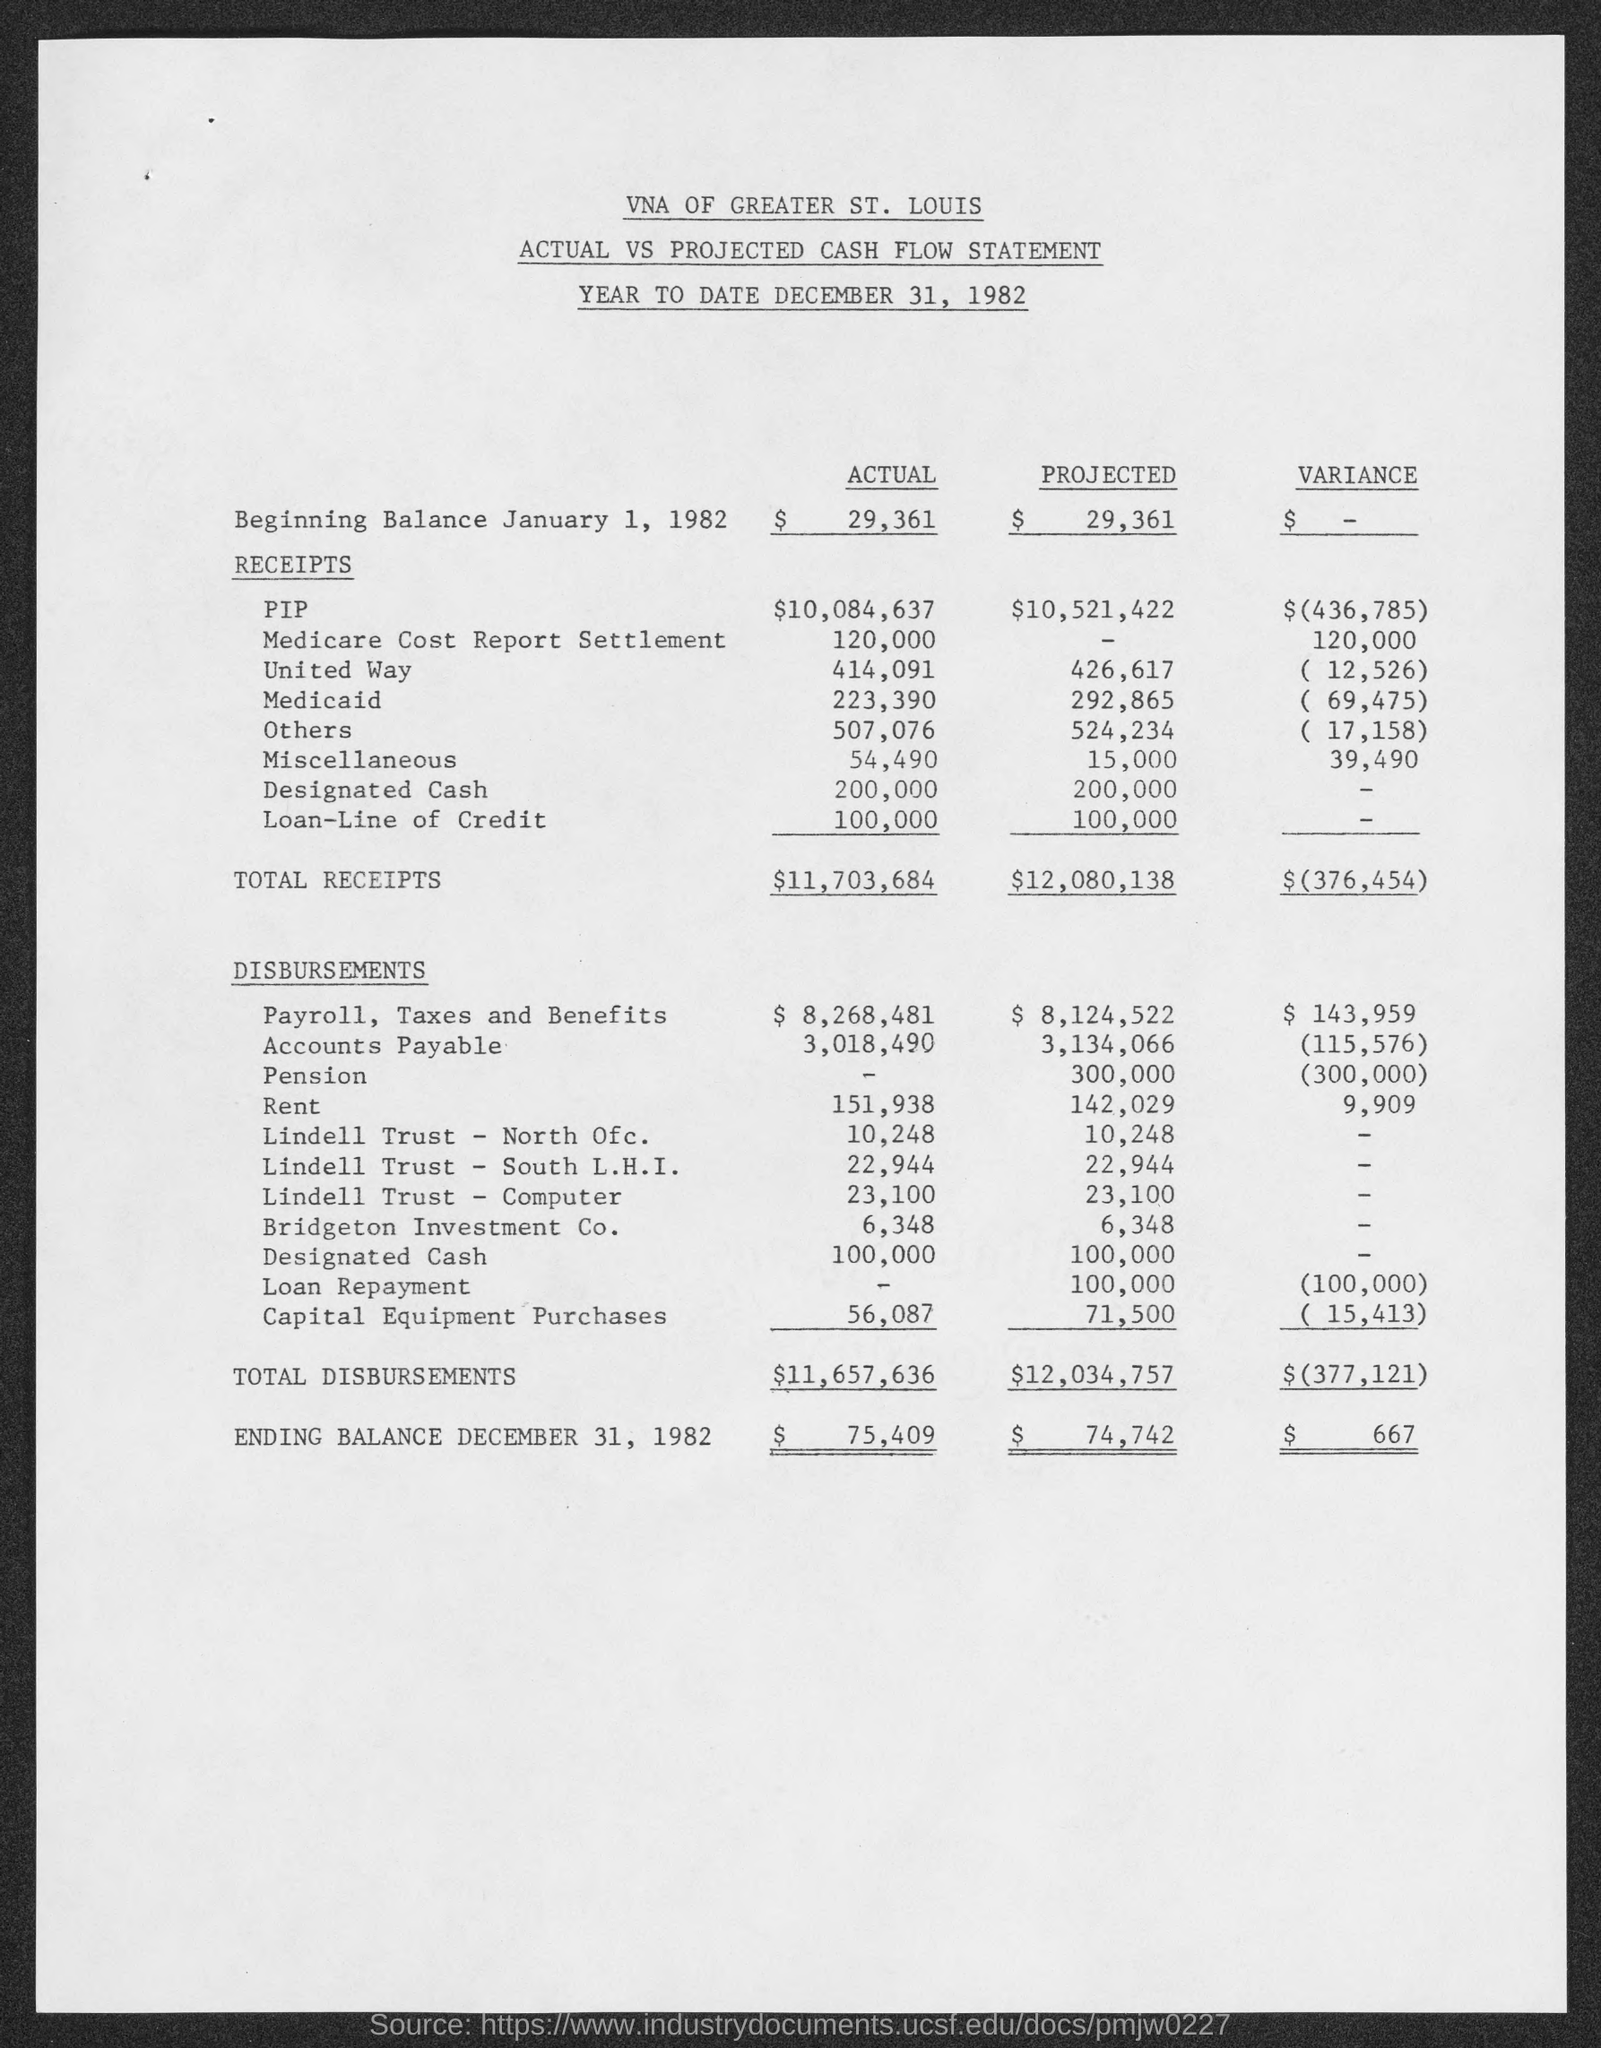What is the Year to Date of Cash Flow Statement ?
Make the answer very short. December 31, 1982. How much is the Total Receipts of Actual ?
Your answer should be very brief. $11,703,684. How much the Total Receipts of Variance ?
Make the answer very short. $(376,454). How much the Total Disbursements of Actual ?
Provide a succinct answer. $11,657,636. How much is the Total Disbursements of Projected ?
Make the answer very short. $12,034,757. How much is the Total Disbursements of Variance ?
Give a very brief answer. $(377,121). What is the Ending Balance December 31, 1982 of Actual ?
Ensure brevity in your answer.  $ 75,409. 